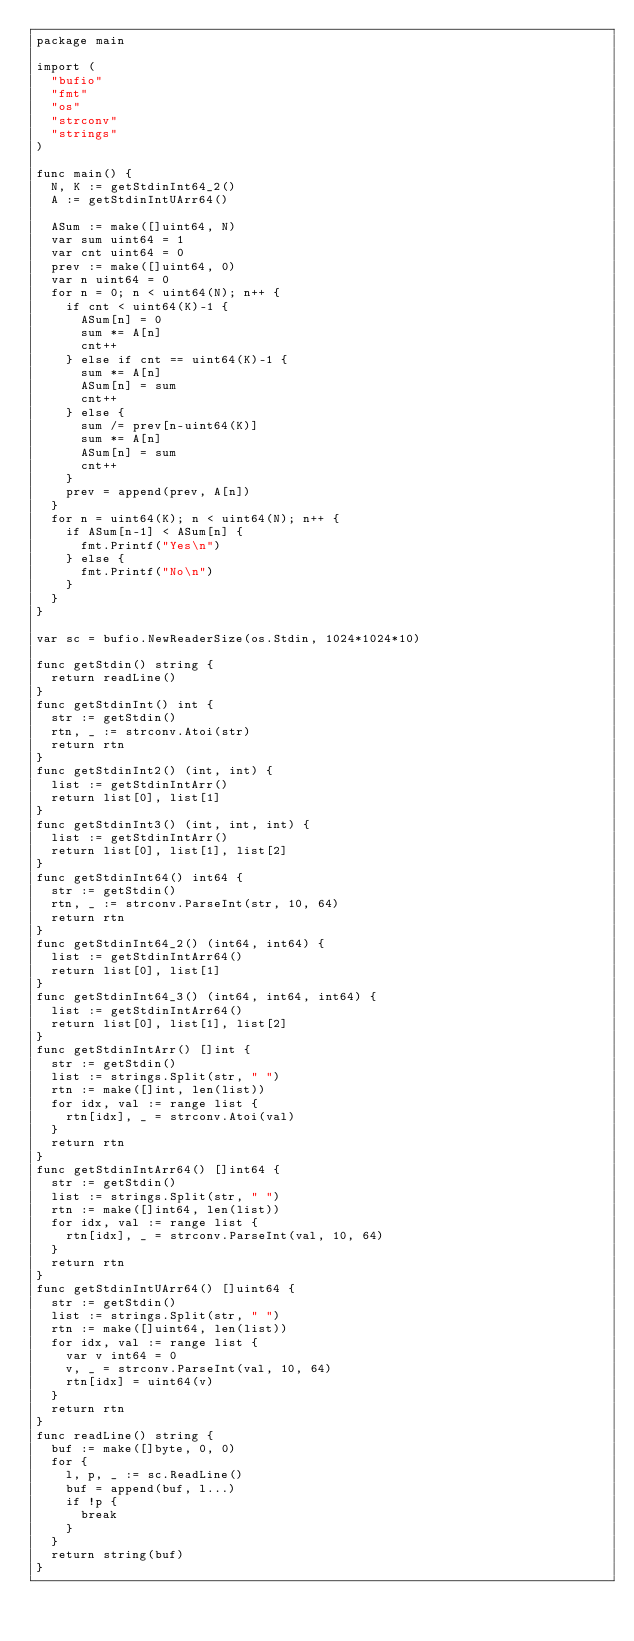Convert code to text. <code><loc_0><loc_0><loc_500><loc_500><_Go_>package main

import (
	"bufio"
	"fmt"
	"os"
	"strconv"
	"strings"
)

func main() {
	N, K := getStdinInt64_2()
	A := getStdinIntUArr64()

	ASum := make([]uint64, N)
	var sum uint64 = 1
	var cnt uint64 = 0
	prev := make([]uint64, 0)
	var n uint64 = 0
	for n = 0; n < uint64(N); n++ {
		if cnt < uint64(K)-1 {
			ASum[n] = 0
			sum *= A[n]
			cnt++
		} else if cnt == uint64(K)-1 {
			sum *= A[n]
			ASum[n] = sum
			cnt++
		} else {
			sum /= prev[n-uint64(K)]
			sum *= A[n]
			ASum[n] = sum
			cnt++
		}
		prev = append(prev, A[n])
	}
	for n = uint64(K); n < uint64(N); n++ {
		if ASum[n-1] < ASum[n] {
			fmt.Printf("Yes\n")
		} else {
			fmt.Printf("No\n")
		}
	}
}

var sc = bufio.NewReaderSize(os.Stdin, 1024*1024*10)

func getStdin() string {
	return readLine()
}
func getStdinInt() int {
	str := getStdin()
	rtn, _ := strconv.Atoi(str)
	return rtn
}
func getStdinInt2() (int, int) {
	list := getStdinIntArr()
	return list[0], list[1]
}
func getStdinInt3() (int, int, int) {
	list := getStdinIntArr()
	return list[0], list[1], list[2]
}
func getStdinInt64() int64 {
	str := getStdin()
	rtn, _ := strconv.ParseInt(str, 10, 64)
	return rtn
}
func getStdinInt64_2() (int64, int64) {
	list := getStdinIntArr64()
	return list[0], list[1]
}
func getStdinInt64_3() (int64, int64, int64) {
	list := getStdinIntArr64()
	return list[0], list[1], list[2]
}
func getStdinIntArr() []int {
	str := getStdin()
	list := strings.Split(str, " ")
	rtn := make([]int, len(list))
	for idx, val := range list {
		rtn[idx], _ = strconv.Atoi(val)
	}
	return rtn
}
func getStdinIntArr64() []int64 {
	str := getStdin()
	list := strings.Split(str, " ")
	rtn := make([]int64, len(list))
	for idx, val := range list {
		rtn[idx], _ = strconv.ParseInt(val, 10, 64)
	}
	return rtn
}
func getStdinIntUArr64() []uint64 {
	str := getStdin()
	list := strings.Split(str, " ")
	rtn := make([]uint64, len(list))
	for idx, val := range list {
		var v int64 = 0
		v, _ = strconv.ParseInt(val, 10, 64)
		rtn[idx] = uint64(v)
	}
	return rtn
}
func readLine() string {
	buf := make([]byte, 0, 0)
	for {
		l, p, _ := sc.ReadLine()
		buf = append(buf, l...)
		if !p {
			break
		}
	}
	return string(buf)
}
</code> 